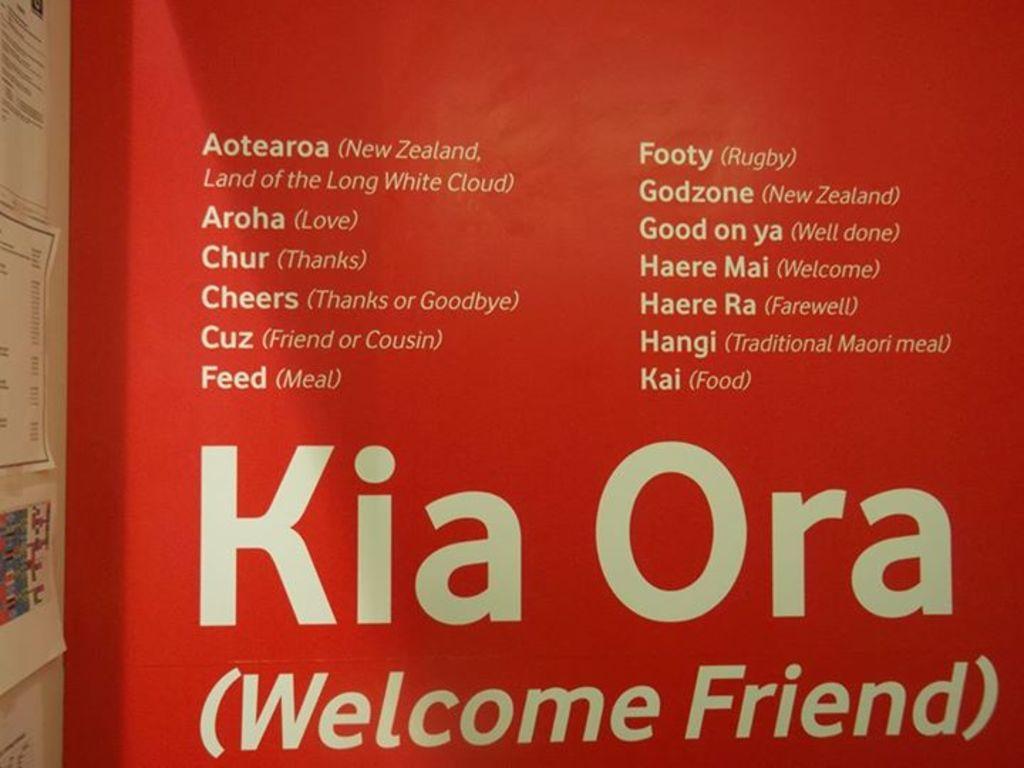How would you summarize this image in a sentence or two? In this image we can see a hoarding and there is something written on it. On the left side of the image we can see posters. 